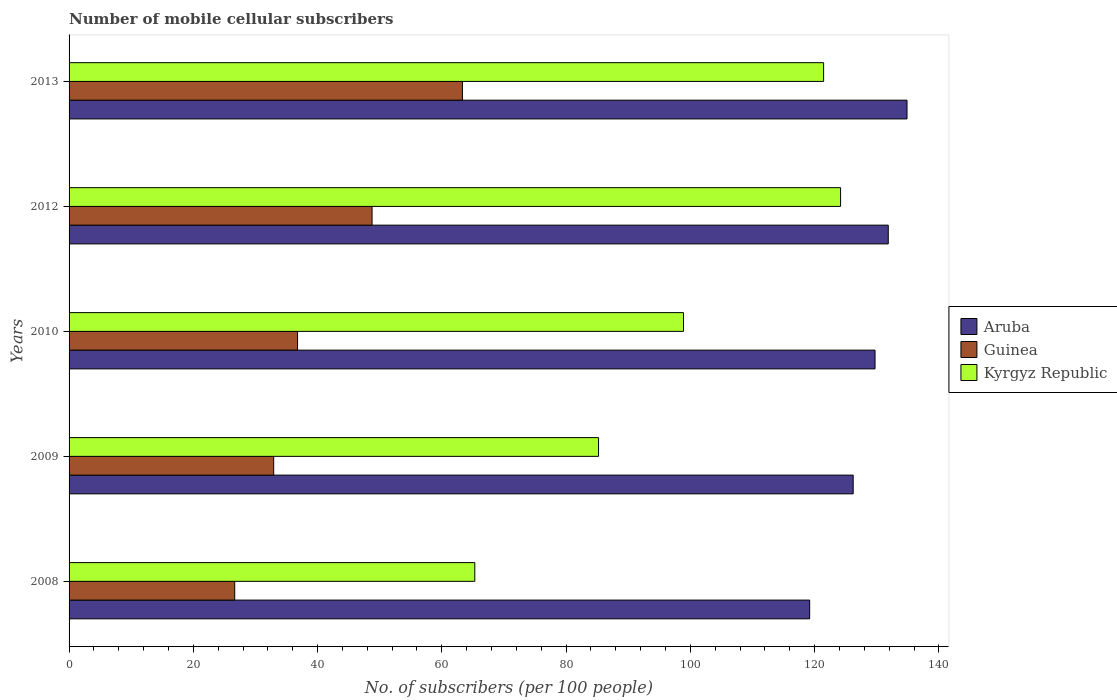Are the number of bars per tick equal to the number of legend labels?
Offer a very short reply. Yes. How many bars are there on the 1st tick from the bottom?
Make the answer very short. 3. What is the label of the 2nd group of bars from the top?
Ensure brevity in your answer.  2012. What is the number of mobile cellular subscribers in Guinea in 2010?
Provide a short and direct response. 36.78. Across all years, what is the maximum number of mobile cellular subscribers in Kyrgyz Republic?
Keep it short and to the point. 124.18. Across all years, what is the minimum number of mobile cellular subscribers in Kyrgyz Republic?
Your answer should be very brief. 65.3. In which year was the number of mobile cellular subscribers in Kyrgyz Republic maximum?
Your response must be concise. 2012. In which year was the number of mobile cellular subscribers in Guinea minimum?
Your answer should be very brief. 2008. What is the total number of mobile cellular subscribers in Aruba in the graph?
Offer a terse response. 641.87. What is the difference between the number of mobile cellular subscribers in Aruba in 2008 and that in 2012?
Ensure brevity in your answer.  -12.65. What is the difference between the number of mobile cellular subscribers in Aruba in 2008 and the number of mobile cellular subscribers in Kyrgyz Republic in 2013?
Offer a very short reply. -2.25. What is the average number of mobile cellular subscribers in Guinea per year?
Offer a terse response. 41.69. In the year 2008, what is the difference between the number of mobile cellular subscribers in Kyrgyz Republic and number of mobile cellular subscribers in Aruba?
Your response must be concise. -53.9. In how many years, is the number of mobile cellular subscribers in Kyrgyz Republic greater than 96 ?
Your response must be concise. 3. What is the ratio of the number of mobile cellular subscribers in Guinea in 2010 to that in 2012?
Provide a succinct answer. 0.75. Is the number of mobile cellular subscribers in Kyrgyz Republic in 2008 less than that in 2013?
Your answer should be compact. Yes. Is the difference between the number of mobile cellular subscribers in Kyrgyz Republic in 2008 and 2012 greater than the difference between the number of mobile cellular subscribers in Aruba in 2008 and 2012?
Your response must be concise. No. What is the difference between the highest and the second highest number of mobile cellular subscribers in Kyrgyz Republic?
Provide a succinct answer. 2.73. What is the difference between the highest and the lowest number of mobile cellular subscribers in Aruba?
Provide a succinct answer. 15.67. In how many years, is the number of mobile cellular subscribers in Kyrgyz Republic greater than the average number of mobile cellular subscribers in Kyrgyz Republic taken over all years?
Your answer should be compact. 2. Is the sum of the number of mobile cellular subscribers in Aruba in 2009 and 2010 greater than the maximum number of mobile cellular subscribers in Guinea across all years?
Make the answer very short. Yes. What does the 1st bar from the top in 2012 represents?
Offer a very short reply. Kyrgyz Republic. What does the 1st bar from the bottom in 2013 represents?
Offer a very short reply. Aruba. What is the difference between two consecutive major ticks on the X-axis?
Your answer should be very brief. 20. Does the graph contain grids?
Offer a very short reply. No. What is the title of the graph?
Your response must be concise. Number of mobile cellular subscribers. What is the label or title of the X-axis?
Offer a terse response. No. of subscribers (per 100 people). What is the label or title of the Y-axis?
Make the answer very short. Years. What is the No. of subscribers (per 100 people) in Aruba in 2008?
Give a very brief answer. 119.2. What is the No. of subscribers (per 100 people) in Guinea in 2008?
Your response must be concise. 26.66. What is the No. of subscribers (per 100 people) in Kyrgyz Republic in 2008?
Ensure brevity in your answer.  65.3. What is the No. of subscribers (per 100 people) in Aruba in 2009?
Keep it short and to the point. 126.21. What is the No. of subscribers (per 100 people) in Guinea in 2009?
Your response must be concise. 32.94. What is the No. of subscribers (per 100 people) of Kyrgyz Republic in 2009?
Provide a short and direct response. 85.22. What is the No. of subscribers (per 100 people) of Aruba in 2010?
Your answer should be compact. 129.73. What is the No. of subscribers (per 100 people) of Guinea in 2010?
Keep it short and to the point. 36.78. What is the No. of subscribers (per 100 people) of Kyrgyz Republic in 2010?
Keep it short and to the point. 98.9. What is the No. of subscribers (per 100 people) in Aruba in 2012?
Your answer should be very brief. 131.86. What is the No. of subscribers (per 100 people) of Guinea in 2012?
Your answer should be very brief. 48.77. What is the No. of subscribers (per 100 people) in Kyrgyz Republic in 2012?
Give a very brief answer. 124.18. What is the No. of subscribers (per 100 people) in Aruba in 2013?
Offer a very short reply. 134.87. What is the No. of subscribers (per 100 people) in Guinea in 2013?
Your answer should be very brief. 63.32. What is the No. of subscribers (per 100 people) of Kyrgyz Republic in 2013?
Ensure brevity in your answer.  121.45. Across all years, what is the maximum No. of subscribers (per 100 people) of Aruba?
Your answer should be compact. 134.87. Across all years, what is the maximum No. of subscribers (per 100 people) in Guinea?
Provide a short and direct response. 63.32. Across all years, what is the maximum No. of subscribers (per 100 people) in Kyrgyz Republic?
Your answer should be compact. 124.18. Across all years, what is the minimum No. of subscribers (per 100 people) of Aruba?
Offer a terse response. 119.2. Across all years, what is the minimum No. of subscribers (per 100 people) of Guinea?
Your answer should be very brief. 26.66. Across all years, what is the minimum No. of subscribers (per 100 people) in Kyrgyz Republic?
Provide a short and direct response. 65.3. What is the total No. of subscribers (per 100 people) of Aruba in the graph?
Offer a terse response. 641.87. What is the total No. of subscribers (per 100 people) in Guinea in the graph?
Provide a succinct answer. 208.46. What is the total No. of subscribers (per 100 people) of Kyrgyz Republic in the graph?
Your answer should be compact. 495.05. What is the difference between the No. of subscribers (per 100 people) in Aruba in 2008 and that in 2009?
Offer a very short reply. -7.01. What is the difference between the No. of subscribers (per 100 people) in Guinea in 2008 and that in 2009?
Your response must be concise. -6.28. What is the difference between the No. of subscribers (per 100 people) of Kyrgyz Republic in 2008 and that in 2009?
Offer a very short reply. -19.92. What is the difference between the No. of subscribers (per 100 people) in Aruba in 2008 and that in 2010?
Ensure brevity in your answer.  -10.52. What is the difference between the No. of subscribers (per 100 people) of Guinea in 2008 and that in 2010?
Give a very brief answer. -10.12. What is the difference between the No. of subscribers (per 100 people) of Kyrgyz Republic in 2008 and that in 2010?
Provide a short and direct response. -33.59. What is the difference between the No. of subscribers (per 100 people) in Aruba in 2008 and that in 2012?
Give a very brief answer. -12.65. What is the difference between the No. of subscribers (per 100 people) of Guinea in 2008 and that in 2012?
Your answer should be compact. -22.11. What is the difference between the No. of subscribers (per 100 people) of Kyrgyz Republic in 2008 and that in 2012?
Give a very brief answer. -58.88. What is the difference between the No. of subscribers (per 100 people) of Aruba in 2008 and that in 2013?
Make the answer very short. -15.67. What is the difference between the No. of subscribers (per 100 people) in Guinea in 2008 and that in 2013?
Your answer should be very brief. -36.65. What is the difference between the No. of subscribers (per 100 people) of Kyrgyz Republic in 2008 and that in 2013?
Keep it short and to the point. -56.15. What is the difference between the No. of subscribers (per 100 people) in Aruba in 2009 and that in 2010?
Your response must be concise. -3.52. What is the difference between the No. of subscribers (per 100 people) in Guinea in 2009 and that in 2010?
Keep it short and to the point. -3.84. What is the difference between the No. of subscribers (per 100 people) in Kyrgyz Republic in 2009 and that in 2010?
Offer a terse response. -13.68. What is the difference between the No. of subscribers (per 100 people) of Aruba in 2009 and that in 2012?
Your response must be concise. -5.65. What is the difference between the No. of subscribers (per 100 people) in Guinea in 2009 and that in 2012?
Make the answer very short. -15.83. What is the difference between the No. of subscribers (per 100 people) in Kyrgyz Republic in 2009 and that in 2012?
Ensure brevity in your answer.  -38.96. What is the difference between the No. of subscribers (per 100 people) in Aruba in 2009 and that in 2013?
Make the answer very short. -8.66. What is the difference between the No. of subscribers (per 100 people) in Guinea in 2009 and that in 2013?
Provide a succinct answer. -30.38. What is the difference between the No. of subscribers (per 100 people) of Kyrgyz Republic in 2009 and that in 2013?
Give a very brief answer. -36.23. What is the difference between the No. of subscribers (per 100 people) of Aruba in 2010 and that in 2012?
Give a very brief answer. -2.13. What is the difference between the No. of subscribers (per 100 people) of Guinea in 2010 and that in 2012?
Ensure brevity in your answer.  -11.99. What is the difference between the No. of subscribers (per 100 people) in Kyrgyz Republic in 2010 and that in 2012?
Give a very brief answer. -25.28. What is the difference between the No. of subscribers (per 100 people) in Aruba in 2010 and that in 2013?
Make the answer very short. -5.15. What is the difference between the No. of subscribers (per 100 people) of Guinea in 2010 and that in 2013?
Give a very brief answer. -26.54. What is the difference between the No. of subscribers (per 100 people) in Kyrgyz Republic in 2010 and that in 2013?
Provide a succinct answer. -22.55. What is the difference between the No. of subscribers (per 100 people) in Aruba in 2012 and that in 2013?
Make the answer very short. -3.02. What is the difference between the No. of subscribers (per 100 people) of Guinea in 2012 and that in 2013?
Ensure brevity in your answer.  -14.55. What is the difference between the No. of subscribers (per 100 people) in Kyrgyz Republic in 2012 and that in 2013?
Give a very brief answer. 2.73. What is the difference between the No. of subscribers (per 100 people) in Aruba in 2008 and the No. of subscribers (per 100 people) in Guinea in 2009?
Provide a short and direct response. 86.27. What is the difference between the No. of subscribers (per 100 people) of Aruba in 2008 and the No. of subscribers (per 100 people) of Kyrgyz Republic in 2009?
Give a very brief answer. 33.98. What is the difference between the No. of subscribers (per 100 people) of Guinea in 2008 and the No. of subscribers (per 100 people) of Kyrgyz Republic in 2009?
Your answer should be compact. -58.56. What is the difference between the No. of subscribers (per 100 people) of Aruba in 2008 and the No. of subscribers (per 100 people) of Guinea in 2010?
Your answer should be very brief. 82.43. What is the difference between the No. of subscribers (per 100 people) of Aruba in 2008 and the No. of subscribers (per 100 people) of Kyrgyz Republic in 2010?
Give a very brief answer. 20.31. What is the difference between the No. of subscribers (per 100 people) in Guinea in 2008 and the No. of subscribers (per 100 people) in Kyrgyz Republic in 2010?
Offer a very short reply. -72.24. What is the difference between the No. of subscribers (per 100 people) of Aruba in 2008 and the No. of subscribers (per 100 people) of Guinea in 2012?
Give a very brief answer. 70.43. What is the difference between the No. of subscribers (per 100 people) in Aruba in 2008 and the No. of subscribers (per 100 people) in Kyrgyz Republic in 2012?
Provide a short and direct response. -4.98. What is the difference between the No. of subscribers (per 100 people) of Guinea in 2008 and the No. of subscribers (per 100 people) of Kyrgyz Republic in 2012?
Keep it short and to the point. -97.52. What is the difference between the No. of subscribers (per 100 people) of Aruba in 2008 and the No. of subscribers (per 100 people) of Guinea in 2013?
Provide a succinct answer. 55.89. What is the difference between the No. of subscribers (per 100 people) in Aruba in 2008 and the No. of subscribers (per 100 people) in Kyrgyz Republic in 2013?
Give a very brief answer. -2.25. What is the difference between the No. of subscribers (per 100 people) in Guinea in 2008 and the No. of subscribers (per 100 people) in Kyrgyz Republic in 2013?
Your response must be concise. -94.79. What is the difference between the No. of subscribers (per 100 people) of Aruba in 2009 and the No. of subscribers (per 100 people) of Guinea in 2010?
Make the answer very short. 89.43. What is the difference between the No. of subscribers (per 100 people) in Aruba in 2009 and the No. of subscribers (per 100 people) in Kyrgyz Republic in 2010?
Your answer should be compact. 27.31. What is the difference between the No. of subscribers (per 100 people) of Guinea in 2009 and the No. of subscribers (per 100 people) of Kyrgyz Republic in 2010?
Ensure brevity in your answer.  -65.96. What is the difference between the No. of subscribers (per 100 people) of Aruba in 2009 and the No. of subscribers (per 100 people) of Guinea in 2012?
Provide a succinct answer. 77.44. What is the difference between the No. of subscribers (per 100 people) of Aruba in 2009 and the No. of subscribers (per 100 people) of Kyrgyz Republic in 2012?
Provide a succinct answer. 2.03. What is the difference between the No. of subscribers (per 100 people) in Guinea in 2009 and the No. of subscribers (per 100 people) in Kyrgyz Republic in 2012?
Your response must be concise. -91.24. What is the difference between the No. of subscribers (per 100 people) of Aruba in 2009 and the No. of subscribers (per 100 people) of Guinea in 2013?
Your answer should be compact. 62.9. What is the difference between the No. of subscribers (per 100 people) of Aruba in 2009 and the No. of subscribers (per 100 people) of Kyrgyz Republic in 2013?
Make the answer very short. 4.76. What is the difference between the No. of subscribers (per 100 people) of Guinea in 2009 and the No. of subscribers (per 100 people) of Kyrgyz Republic in 2013?
Your response must be concise. -88.51. What is the difference between the No. of subscribers (per 100 people) in Aruba in 2010 and the No. of subscribers (per 100 people) in Guinea in 2012?
Keep it short and to the point. 80.96. What is the difference between the No. of subscribers (per 100 people) in Aruba in 2010 and the No. of subscribers (per 100 people) in Kyrgyz Republic in 2012?
Your answer should be compact. 5.55. What is the difference between the No. of subscribers (per 100 people) in Guinea in 2010 and the No. of subscribers (per 100 people) in Kyrgyz Republic in 2012?
Offer a very short reply. -87.4. What is the difference between the No. of subscribers (per 100 people) in Aruba in 2010 and the No. of subscribers (per 100 people) in Guinea in 2013?
Your answer should be very brief. 66.41. What is the difference between the No. of subscribers (per 100 people) of Aruba in 2010 and the No. of subscribers (per 100 people) of Kyrgyz Republic in 2013?
Offer a terse response. 8.28. What is the difference between the No. of subscribers (per 100 people) in Guinea in 2010 and the No. of subscribers (per 100 people) in Kyrgyz Republic in 2013?
Your answer should be compact. -84.67. What is the difference between the No. of subscribers (per 100 people) in Aruba in 2012 and the No. of subscribers (per 100 people) in Guinea in 2013?
Give a very brief answer. 68.54. What is the difference between the No. of subscribers (per 100 people) in Aruba in 2012 and the No. of subscribers (per 100 people) in Kyrgyz Republic in 2013?
Provide a short and direct response. 10.41. What is the difference between the No. of subscribers (per 100 people) in Guinea in 2012 and the No. of subscribers (per 100 people) in Kyrgyz Republic in 2013?
Give a very brief answer. -72.68. What is the average No. of subscribers (per 100 people) of Aruba per year?
Your answer should be compact. 128.37. What is the average No. of subscribers (per 100 people) of Guinea per year?
Keep it short and to the point. 41.69. What is the average No. of subscribers (per 100 people) in Kyrgyz Republic per year?
Provide a short and direct response. 99.01. In the year 2008, what is the difference between the No. of subscribers (per 100 people) of Aruba and No. of subscribers (per 100 people) of Guinea?
Keep it short and to the point. 92.54. In the year 2008, what is the difference between the No. of subscribers (per 100 people) of Aruba and No. of subscribers (per 100 people) of Kyrgyz Republic?
Provide a short and direct response. 53.9. In the year 2008, what is the difference between the No. of subscribers (per 100 people) in Guinea and No. of subscribers (per 100 people) in Kyrgyz Republic?
Your answer should be compact. -38.64. In the year 2009, what is the difference between the No. of subscribers (per 100 people) in Aruba and No. of subscribers (per 100 people) in Guinea?
Keep it short and to the point. 93.27. In the year 2009, what is the difference between the No. of subscribers (per 100 people) of Aruba and No. of subscribers (per 100 people) of Kyrgyz Republic?
Offer a terse response. 40.99. In the year 2009, what is the difference between the No. of subscribers (per 100 people) of Guinea and No. of subscribers (per 100 people) of Kyrgyz Republic?
Your answer should be compact. -52.29. In the year 2010, what is the difference between the No. of subscribers (per 100 people) of Aruba and No. of subscribers (per 100 people) of Guinea?
Keep it short and to the point. 92.95. In the year 2010, what is the difference between the No. of subscribers (per 100 people) of Aruba and No. of subscribers (per 100 people) of Kyrgyz Republic?
Provide a succinct answer. 30.83. In the year 2010, what is the difference between the No. of subscribers (per 100 people) in Guinea and No. of subscribers (per 100 people) in Kyrgyz Republic?
Your answer should be compact. -62.12. In the year 2012, what is the difference between the No. of subscribers (per 100 people) in Aruba and No. of subscribers (per 100 people) in Guinea?
Keep it short and to the point. 83.09. In the year 2012, what is the difference between the No. of subscribers (per 100 people) in Aruba and No. of subscribers (per 100 people) in Kyrgyz Republic?
Ensure brevity in your answer.  7.68. In the year 2012, what is the difference between the No. of subscribers (per 100 people) of Guinea and No. of subscribers (per 100 people) of Kyrgyz Republic?
Your response must be concise. -75.41. In the year 2013, what is the difference between the No. of subscribers (per 100 people) of Aruba and No. of subscribers (per 100 people) of Guinea?
Offer a very short reply. 71.56. In the year 2013, what is the difference between the No. of subscribers (per 100 people) of Aruba and No. of subscribers (per 100 people) of Kyrgyz Republic?
Your answer should be compact. 13.42. In the year 2013, what is the difference between the No. of subscribers (per 100 people) of Guinea and No. of subscribers (per 100 people) of Kyrgyz Republic?
Provide a succinct answer. -58.13. What is the ratio of the No. of subscribers (per 100 people) of Aruba in 2008 to that in 2009?
Give a very brief answer. 0.94. What is the ratio of the No. of subscribers (per 100 people) of Guinea in 2008 to that in 2009?
Offer a very short reply. 0.81. What is the ratio of the No. of subscribers (per 100 people) in Kyrgyz Republic in 2008 to that in 2009?
Give a very brief answer. 0.77. What is the ratio of the No. of subscribers (per 100 people) in Aruba in 2008 to that in 2010?
Keep it short and to the point. 0.92. What is the ratio of the No. of subscribers (per 100 people) in Guinea in 2008 to that in 2010?
Your response must be concise. 0.72. What is the ratio of the No. of subscribers (per 100 people) in Kyrgyz Republic in 2008 to that in 2010?
Ensure brevity in your answer.  0.66. What is the ratio of the No. of subscribers (per 100 people) of Aruba in 2008 to that in 2012?
Your response must be concise. 0.9. What is the ratio of the No. of subscribers (per 100 people) in Guinea in 2008 to that in 2012?
Offer a very short reply. 0.55. What is the ratio of the No. of subscribers (per 100 people) in Kyrgyz Republic in 2008 to that in 2012?
Offer a very short reply. 0.53. What is the ratio of the No. of subscribers (per 100 people) in Aruba in 2008 to that in 2013?
Provide a short and direct response. 0.88. What is the ratio of the No. of subscribers (per 100 people) of Guinea in 2008 to that in 2013?
Your answer should be very brief. 0.42. What is the ratio of the No. of subscribers (per 100 people) of Kyrgyz Republic in 2008 to that in 2013?
Your answer should be compact. 0.54. What is the ratio of the No. of subscribers (per 100 people) in Aruba in 2009 to that in 2010?
Your response must be concise. 0.97. What is the ratio of the No. of subscribers (per 100 people) of Guinea in 2009 to that in 2010?
Make the answer very short. 0.9. What is the ratio of the No. of subscribers (per 100 people) in Kyrgyz Republic in 2009 to that in 2010?
Your response must be concise. 0.86. What is the ratio of the No. of subscribers (per 100 people) of Aruba in 2009 to that in 2012?
Make the answer very short. 0.96. What is the ratio of the No. of subscribers (per 100 people) of Guinea in 2009 to that in 2012?
Offer a very short reply. 0.68. What is the ratio of the No. of subscribers (per 100 people) of Kyrgyz Republic in 2009 to that in 2012?
Give a very brief answer. 0.69. What is the ratio of the No. of subscribers (per 100 people) in Aruba in 2009 to that in 2013?
Give a very brief answer. 0.94. What is the ratio of the No. of subscribers (per 100 people) in Guinea in 2009 to that in 2013?
Ensure brevity in your answer.  0.52. What is the ratio of the No. of subscribers (per 100 people) in Kyrgyz Republic in 2009 to that in 2013?
Make the answer very short. 0.7. What is the ratio of the No. of subscribers (per 100 people) in Aruba in 2010 to that in 2012?
Provide a succinct answer. 0.98. What is the ratio of the No. of subscribers (per 100 people) of Guinea in 2010 to that in 2012?
Ensure brevity in your answer.  0.75. What is the ratio of the No. of subscribers (per 100 people) in Kyrgyz Republic in 2010 to that in 2012?
Ensure brevity in your answer.  0.8. What is the ratio of the No. of subscribers (per 100 people) in Aruba in 2010 to that in 2013?
Your response must be concise. 0.96. What is the ratio of the No. of subscribers (per 100 people) of Guinea in 2010 to that in 2013?
Provide a short and direct response. 0.58. What is the ratio of the No. of subscribers (per 100 people) of Kyrgyz Republic in 2010 to that in 2013?
Offer a terse response. 0.81. What is the ratio of the No. of subscribers (per 100 people) of Aruba in 2012 to that in 2013?
Your answer should be very brief. 0.98. What is the ratio of the No. of subscribers (per 100 people) of Guinea in 2012 to that in 2013?
Ensure brevity in your answer.  0.77. What is the ratio of the No. of subscribers (per 100 people) of Kyrgyz Republic in 2012 to that in 2013?
Provide a succinct answer. 1.02. What is the difference between the highest and the second highest No. of subscribers (per 100 people) in Aruba?
Your response must be concise. 3.02. What is the difference between the highest and the second highest No. of subscribers (per 100 people) of Guinea?
Offer a very short reply. 14.55. What is the difference between the highest and the second highest No. of subscribers (per 100 people) in Kyrgyz Republic?
Your response must be concise. 2.73. What is the difference between the highest and the lowest No. of subscribers (per 100 people) of Aruba?
Provide a short and direct response. 15.67. What is the difference between the highest and the lowest No. of subscribers (per 100 people) in Guinea?
Your answer should be compact. 36.65. What is the difference between the highest and the lowest No. of subscribers (per 100 people) of Kyrgyz Republic?
Your answer should be compact. 58.88. 